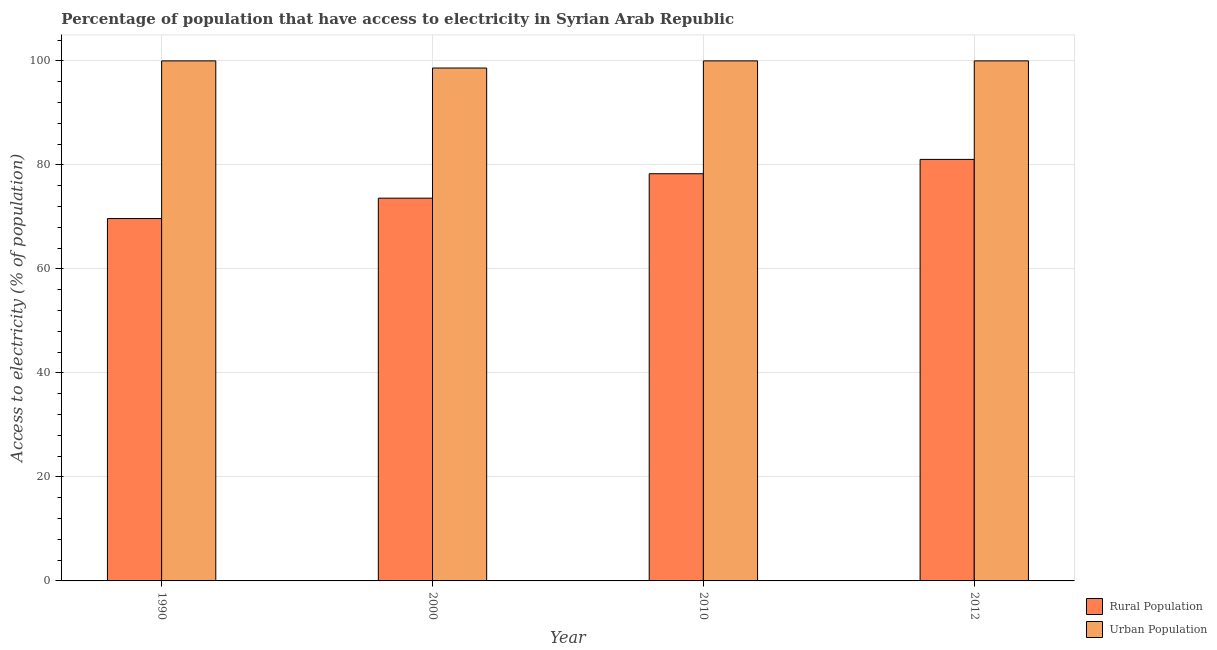How many different coloured bars are there?
Keep it short and to the point. 2. Are the number of bars per tick equal to the number of legend labels?
Your response must be concise. Yes. Are the number of bars on each tick of the X-axis equal?
Ensure brevity in your answer.  Yes. How many bars are there on the 2nd tick from the right?
Keep it short and to the point. 2. What is the percentage of rural population having access to electricity in 2012?
Your response must be concise. 81.05. Across all years, what is the maximum percentage of urban population having access to electricity?
Make the answer very short. 100. Across all years, what is the minimum percentage of rural population having access to electricity?
Offer a terse response. 69.68. In which year was the percentage of urban population having access to electricity maximum?
Offer a very short reply. 1990. What is the total percentage of rural population having access to electricity in the graph?
Provide a succinct answer. 302.63. What is the difference between the percentage of urban population having access to electricity in 2000 and that in 2010?
Provide a short and direct response. -1.37. What is the average percentage of urban population having access to electricity per year?
Give a very brief answer. 99.66. In the year 2000, what is the difference between the percentage of urban population having access to electricity and percentage of rural population having access to electricity?
Your answer should be very brief. 0. In how many years, is the percentage of urban population having access to electricity greater than 40 %?
Offer a very short reply. 4. What is the ratio of the percentage of rural population having access to electricity in 1990 to that in 2000?
Make the answer very short. 0.95. Is the difference between the percentage of rural population having access to electricity in 1990 and 2010 greater than the difference between the percentage of urban population having access to electricity in 1990 and 2010?
Your answer should be very brief. No. What is the difference between the highest and the second highest percentage of urban population having access to electricity?
Keep it short and to the point. 0. What is the difference between the highest and the lowest percentage of rural population having access to electricity?
Your answer should be compact. 11.38. Is the sum of the percentage of urban population having access to electricity in 1990 and 2012 greater than the maximum percentage of rural population having access to electricity across all years?
Make the answer very short. Yes. What does the 1st bar from the left in 2010 represents?
Offer a terse response. Rural Population. What does the 2nd bar from the right in 1990 represents?
Your answer should be compact. Rural Population. How many bars are there?
Your answer should be compact. 8. How many years are there in the graph?
Provide a succinct answer. 4. What is the difference between two consecutive major ticks on the Y-axis?
Ensure brevity in your answer.  20. Where does the legend appear in the graph?
Keep it short and to the point. Bottom right. How are the legend labels stacked?
Provide a short and direct response. Vertical. What is the title of the graph?
Offer a terse response. Percentage of population that have access to electricity in Syrian Arab Republic. Does "Time to export" appear as one of the legend labels in the graph?
Offer a very short reply. No. What is the label or title of the X-axis?
Your answer should be compact. Year. What is the label or title of the Y-axis?
Your response must be concise. Access to electricity (% of population). What is the Access to electricity (% of population) in Rural Population in 1990?
Make the answer very short. 69.68. What is the Access to electricity (% of population) in Rural Population in 2000?
Your answer should be compact. 73.6. What is the Access to electricity (% of population) in Urban Population in 2000?
Keep it short and to the point. 98.63. What is the Access to electricity (% of population) in Rural Population in 2010?
Offer a very short reply. 78.3. What is the Access to electricity (% of population) in Rural Population in 2012?
Provide a succinct answer. 81.05. Across all years, what is the maximum Access to electricity (% of population) in Rural Population?
Give a very brief answer. 81.05. Across all years, what is the minimum Access to electricity (% of population) of Rural Population?
Your answer should be very brief. 69.68. Across all years, what is the minimum Access to electricity (% of population) of Urban Population?
Keep it short and to the point. 98.63. What is the total Access to electricity (% of population) of Rural Population in the graph?
Keep it short and to the point. 302.63. What is the total Access to electricity (% of population) of Urban Population in the graph?
Offer a very short reply. 398.63. What is the difference between the Access to electricity (% of population) in Rural Population in 1990 and that in 2000?
Keep it short and to the point. -3.92. What is the difference between the Access to electricity (% of population) of Urban Population in 1990 and that in 2000?
Your answer should be very brief. 1.37. What is the difference between the Access to electricity (% of population) of Rural Population in 1990 and that in 2010?
Offer a terse response. -8.62. What is the difference between the Access to electricity (% of population) in Urban Population in 1990 and that in 2010?
Keep it short and to the point. 0. What is the difference between the Access to electricity (% of population) of Rural Population in 1990 and that in 2012?
Provide a short and direct response. -11.38. What is the difference between the Access to electricity (% of population) of Urban Population in 1990 and that in 2012?
Give a very brief answer. 0. What is the difference between the Access to electricity (% of population) in Urban Population in 2000 and that in 2010?
Your response must be concise. -1.37. What is the difference between the Access to electricity (% of population) in Rural Population in 2000 and that in 2012?
Give a very brief answer. -7.45. What is the difference between the Access to electricity (% of population) of Urban Population in 2000 and that in 2012?
Provide a succinct answer. -1.37. What is the difference between the Access to electricity (% of population) in Rural Population in 2010 and that in 2012?
Keep it short and to the point. -2.75. What is the difference between the Access to electricity (% of population) in Urban Population in 2010 and that in 2012?
Provide a succinct answer. 0. What is the difference between the Access to electricity (% of population) of Rural Population in 1990 and the Access to electricity (% of population) of Urban Population in 2000?
Make the answer very short. -28.95. What is the difference between the Access to electricity (% of population) of Rural Population in 1990 and the Access to electricity (% of population) of Urban Population in 2010?
Ensure brevity in your answer.  -30.32. What is the difference between the Access to electricity (% of population) of Rural Population in 1990 and the Access to electricity (% of population) of Urban Population in 2012?
Keep it short and to the point. -30.32. What is the difference between the Access to electricity (% of population) of Rural Population in 2000 and the Access to electricity (% of population) of Urban Population in 2010?
Make the answer very short. -26.4. What is the difference between the Access to electricity (% of population) of Rural Population in 2000 and the Access to electricity (% of population) of Urban Population in 2012?
Provide a short and direct response. -26.4. What is the difference between the Access to electricity (% of population) in Rural Population in 2010 and the Access to electricity (% of population) in Urban Population in 2012?
Your answer should be very brief. -21.7. What is the average Access to electricity (% of population) in Rural Population per year?
Your response must be concise. 75.66. What is the average Access to electricity (% of population) of Urban Population per year?
Your answer should be very brief. 99.66. In the year 1990, what is the difference between the Access to electricity (% of population) of Rural Population and Access to electricity (% of population) of Urban Population?
Offer a terse response. -30.32. In the year 2000, what is the difference between the Access to electricity (% of population) in Rural Population and Access to electricity (% of population) in Urban Population?
Ensure brevity in your answer.  -25.03. In the year 2010, what is the difference between the Access to electricity (% of population) of Rural Population and Access to electricity (% of population) of Urban Population?
Offer a very short reply. -21.7. In the year 2012, what is the difference between the Access to electricity (% of population) in Rural Population and Access to electricity (% of population) in Urban Population?
Give a very brief answer. -18.95. What is the ratio of the Access to electricity (% of population) of Rural Population in 1990 to that in 2000?
Make the answer very short. 0.95. What is the ratio of the Access to electricity (% of population) in Urban Population in 1990 to that in 2000?
Your answer should be compact. 1.01. What is the ratio of the Access to electricity (% of population) of Rural Population in 1990 to that in 2010?
Ensure brevity in your answer.  0.89. What is the ratio of the Access to electricity (% of population) in Urban Population in 1990 to that in 2010?
Your answer should be compact. 1. What is the ratio of the Access to electricity (% of population) of Rural Population in 1990 to that in 2012?
Keep it short and to the point. 0.86. What is the ratio of the Access to electricity (% of population) in Rural Population in 2000 to that in 2010?
Give a very brief answer. 0.94. What is the ratio of the Access to electricity (% of population) of Urban Population in 2000 to that in 2010?
Offer a very short reply. 0.99. What is the ratio of the Access to electricity (% of population) in Rural Population in 2000 to that in 2012?
Provide a short and direct response. 0.91. What is the ratio of the Access to electricity (% of population) in Urban Population in 2000 to that in 2012?
Give a very brief answer. 0.99. What is the difference between the highest and the second highest Access to electricity (% of population) in Rural Population?
Provide a short and direct response. 2.75. What is the difference between the highest and the second highest Access to electricity (% of population) of Urban Population?
Your answer should be very brief. 0. What is the difference between the highest and the lowest Access to electricity (% of population) in Rural Population?
Give a very brief answer. 11.38. What is the difference between the highest and the lowest Access to electricity (% of population) in Urban Population?
Provide a succinct answer. 1.37. 